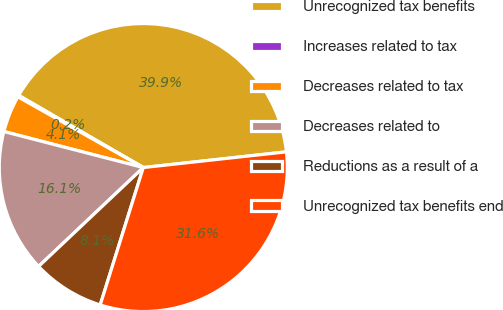Convert chart. <chart><loc_0><loc_0><loc_500><loc_500><pie_chart><fcel>Unrecognized tax benefits<fcel>Increases related to tax<fcel>Decreases related to tax<fcel>Decreases related to<fcel>Reductions as a result of a<fcel>Unrecognized tax benefits end<nl><fcel>39.91%<fcel>0.18%<fcel>4.15%<fcel>16.07%<fcel>8.12%<fcel>31.58%<nl></chart> 